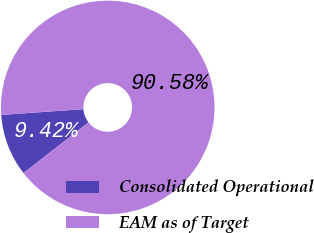<chart> <loc_0><loc_0><loc_500><loc_500><pie_chart><fcel>Consolidated Operational<fcel>EAM as of Target<nl><fcel>9.42%<fcel>90.58%<nl></chart> 